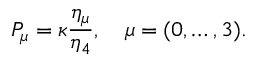Convert formula to latex. <formula><loc_0><loc_0><loc_500><loc_500>P _ { \mu } = \kappa \frac { \eta _ { \mu } } { \eta _ { 4 } } , \quad \mu = ( 0 , \dots , 3 ) .</formula> 